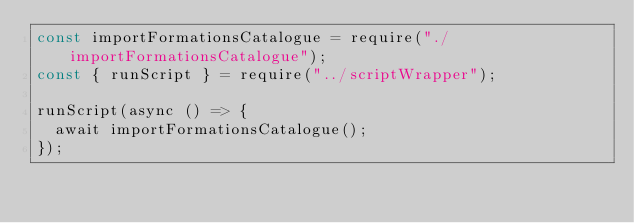<code> <loc_0><loc_0><loc_500><loc_500><_JavaScript_>const importFormationsCatalogue = require("./importFormationsCatalogue");
const { runScript } = require("../scriptWrapper");

runScript(async () => {
  await importFormationsCatalogue();
});
</code> 